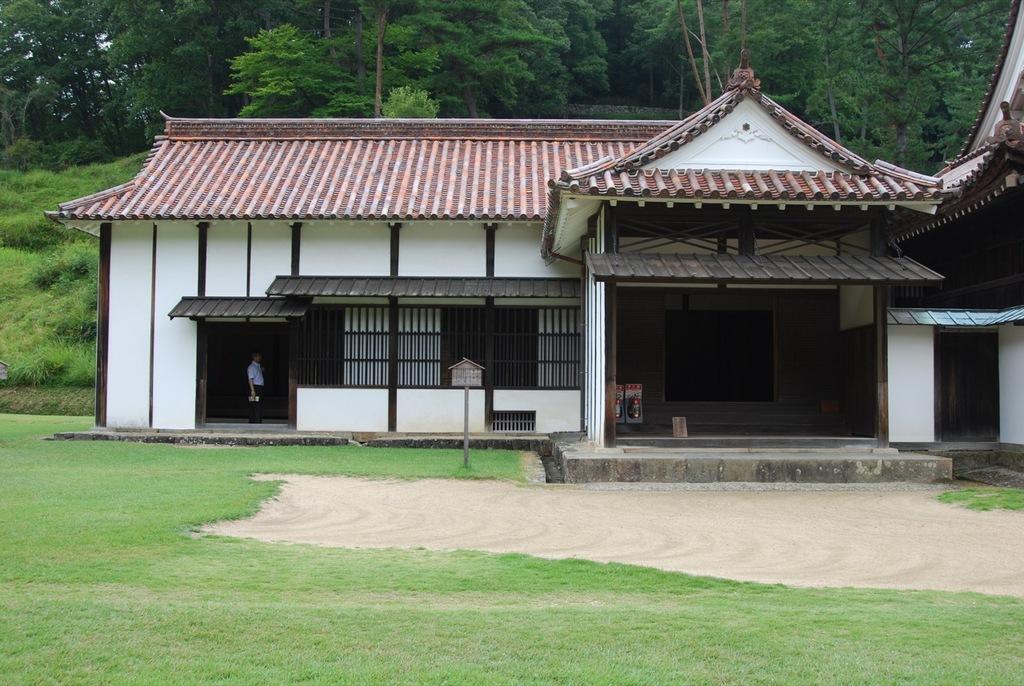Could you give a brief overview of what you see in this image? In this picture we can see a house, roof and a man is standing and holding a book. In the background of the image we can see the trees, grass, plants, boards. At the bottom of the image we can see the ground. 